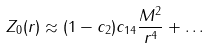Convert formula to latex. <formula><loc_0><loc_0><loc_500><loc_500>Z _ { 0 } ( r ) \approx ( 1 - c _ { 2 } ) c _ { 1 4 } \frac { M ^ { 2 } } { r ^ { 4 } } + \dots</formula> 